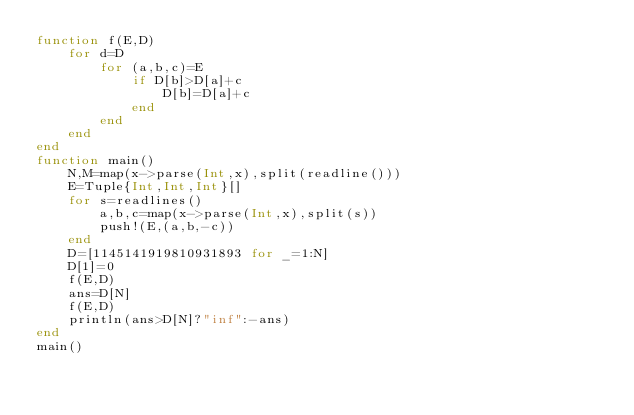<code> <loc_0><loc_0><loc_500><loc_500><_Julia_>function f(E,D)
	for d=D
		for (a,b,c)=E
			if D[b]>D[a]+c
				D[b]=D[a]+c
			end
		end
	end
end
function main()
	N,M=map(x->parse(Int,x),split(readline()))
	E=Tuple{Int,Int,Int}[]
	for s=readlines()
		a,b,c=map(x->parse(Int,x),split(s))
		push!(E,(a,b,-c))
	end
	D=[1145141919810931893 for _=1:N]
	D[1]=0
	f(E,D)
	ans=D[N]
	f(E,D)
	println(ans>D[N]?"inf":-ans)
end
main()
</code> 